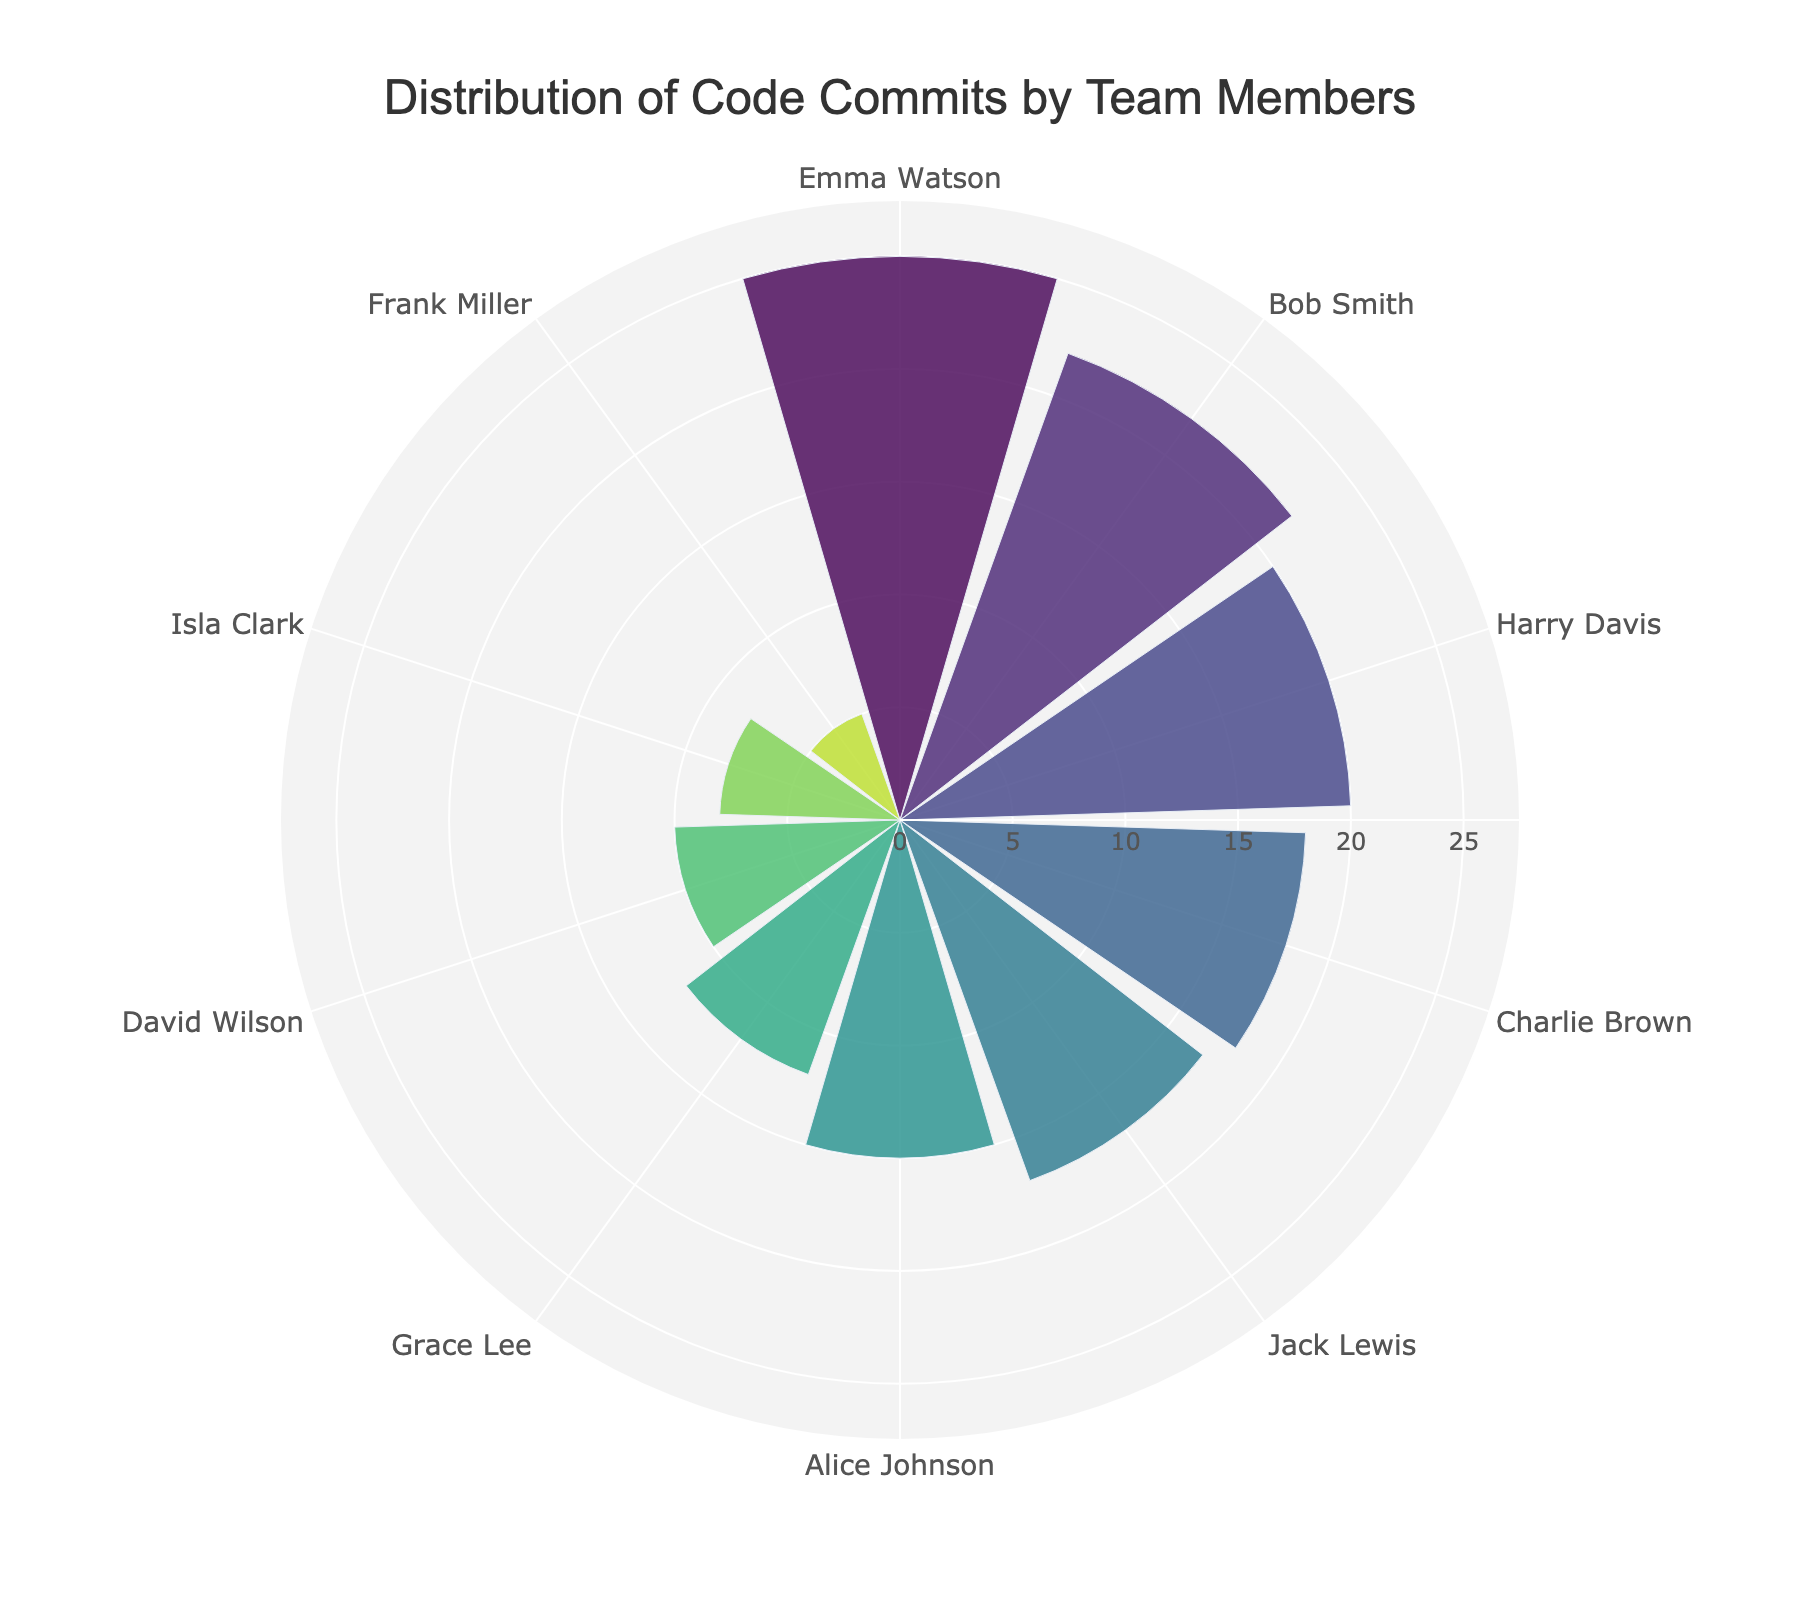What's the title of the chart? The title is displayed at the top center of the chart in a larger font size. The title reads "Distribution of Code Commits by Team Members".
Answer: Distribution of Code Commits by Team Members Which member had the highest number of code commits? The chart displays each team member's commits using the length of the bars. The longest bar represents Emma Watson, indicating she has the highest number of commits, which is 25.
Answer: Emma Watson How many commits did Harry Davis make? By looking at the bar labeled "Harry Davis", you can see the length of the bar stretches to 20 on the radial axis.
Answer: 20 What's the difference between the number of commits made by Alice Johnson and David Wilson? Alice Johnson made 15 commits and David Wilson made 10 commits. The difference is calculated as 15 - 10.
Answer: 5 Who made more commits, Isla Clark or Grace Lee? By comparing the bar lengths labeled "Isla Clark" and "Grace Lee", Grace Lee has a longer bar indicating she made more commits. Grace Lee made 12 commits while Isla Clark made 8 commits.
Answer: Grace Lee How many members made more than 15 commits? Count the bars whose length exceeds 15 on the radial axis. Bob Smith, Charlie Brown, Emma Watson, and Harry Davis each made more than 15 commits. Therefore, there are 4 members.
Answer: 4 Who's the second highest contributor in terms of code commits? The second longest bar represents Bob Smith, indicating he made the second highest number of commits, which is 22.
Answer: Bob Smith How many commits did the top three contributors make in total? The top three contributors are Emma Watson (25), Bob Smith (22), and Harry Davis (20). Summing their commits gives 25 + 22 + 20.
Answer: 67 What's the average number of commits made by all team members? Sum all the commits (15+22+18+10+25+5+12+20+8+17) and divide by the number of members, which is 10. (Sum: 152; Divide: 152/10)
Answer: 15.2 What's the color scheme used in the chart? The chart employs a color gradient that transitions through various shades, part of the 'Viridis' colorscale, which ranges through different hues from yellow to green to blue.
Answer: Viridis 